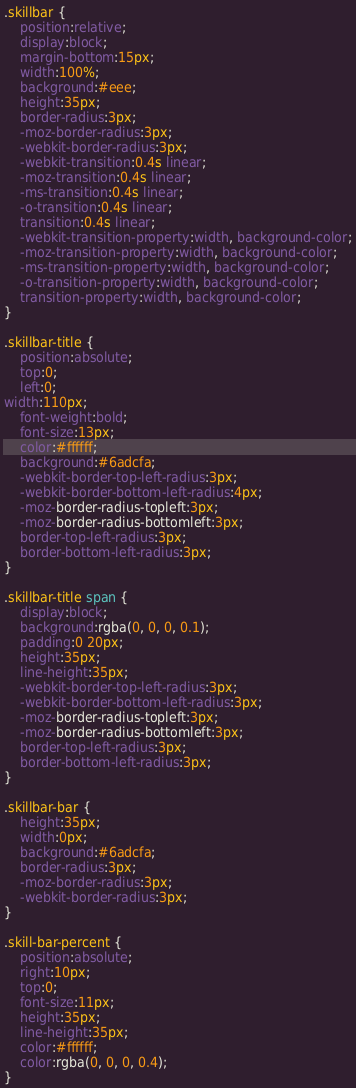<code> <loc_0><loc_0><loc_500><loc_500><_CSS_>.skillbar {
	position:relative;
	display:block;
	margin-bottom:15px;
	width:100%;
	background:#eee;
	height:35px;
	border-radius:3px;
	-moz-border-radius:3px;
	-webkit-border-radius:3px;
	-webkit-transition:0.4s linear;
	-moz-transition:0.4s linear;
	-ms-transition:0.4s linear;
	-o-transition:0.4s linear;
	transition:0.4s linear;
	-webkit-transition-property:width, background-color;
	-moz-transition-property:width, background-color;
	-ms-transition-property:width, background-color;
	-o-transition-property:width, background-color;
	transition-property:width, background-color;
}

.skillbar-title {
	position:absolute;
	top:0;
	left:0;
width:110px;
	font-weight:bold;
	font-size:13px;
	color:#ffffff;
	background:#6adcfa;
	-webkit-border-top-left-radius:3px;
	-webkit-border-bottom-left-radius:4px;
	-moz-border-radius-topleft:3px;
	-moz-border-radius-bottomleft:3px;
	border-top-left-radius:3px;
	border-bottom-left-radius:3px;
}

.skillbar-title span {
	display:block;
	background:rgba(0, 0, 0, 0.1);
	padding:0 20px;
	height:35px;
	line-height:35px;
	-webkit-border-top-left-radius:3px;
	-webkit-border-bottom-left-radius:3px;
	-moz-border-radius-topleft:3px;
	-moz-border-radius-bottomleft:3px;
	border-top-left-radius:3px;
	border-bottom-left-radius:3px;
}

.skillbar-bar {
	height:35px;
	width:0px;
	background:#6adcfa;
	border-radius:3px;
	-moz-border-radius:3px;
	-webkit-border-radius:3px;
}

.skill-bar-percent {
	position:absolute;
	right:10px;
	top:0;
	font-size:11px;
	height:35px;
	line-height:35px;
	color:#ffffff;
	color:rgba(0, 0, 0, 0.4);
}</code> 